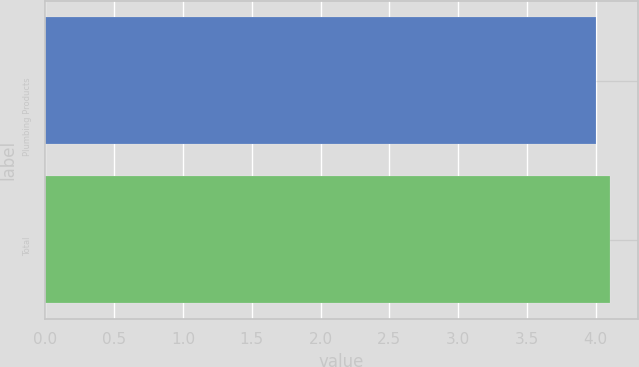<chart> <loc_0><loc_0><loc_500><loc_500><bar_chart><fcel>Plumbing Products<fcel>Total<nl><fcel>4<fcel>4.1<nl></chart> 